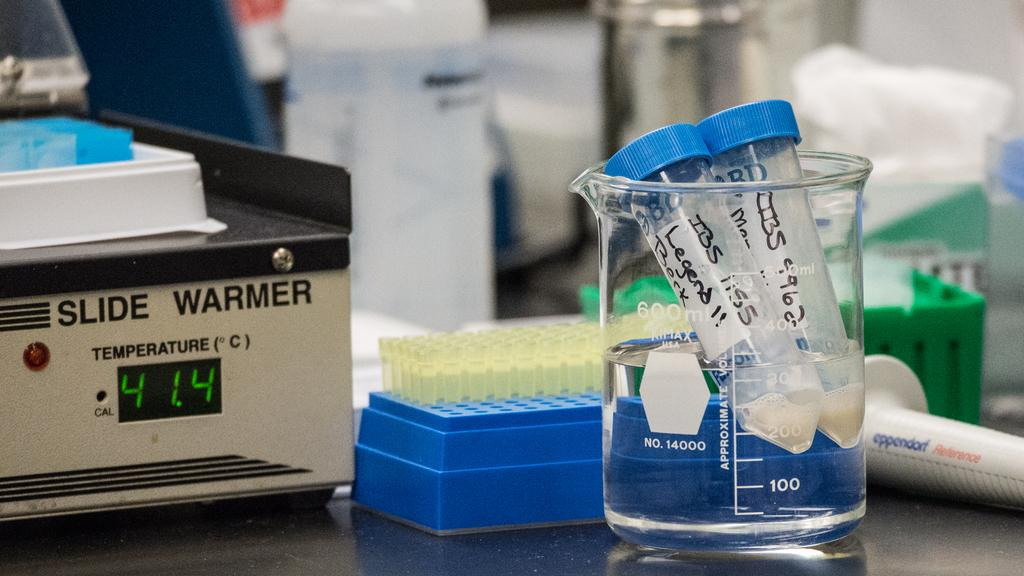<image>
Write a terse but informative summary of the picture. A machine showing the temperature of 41.4 C is sitting on the table next to some tubes. 